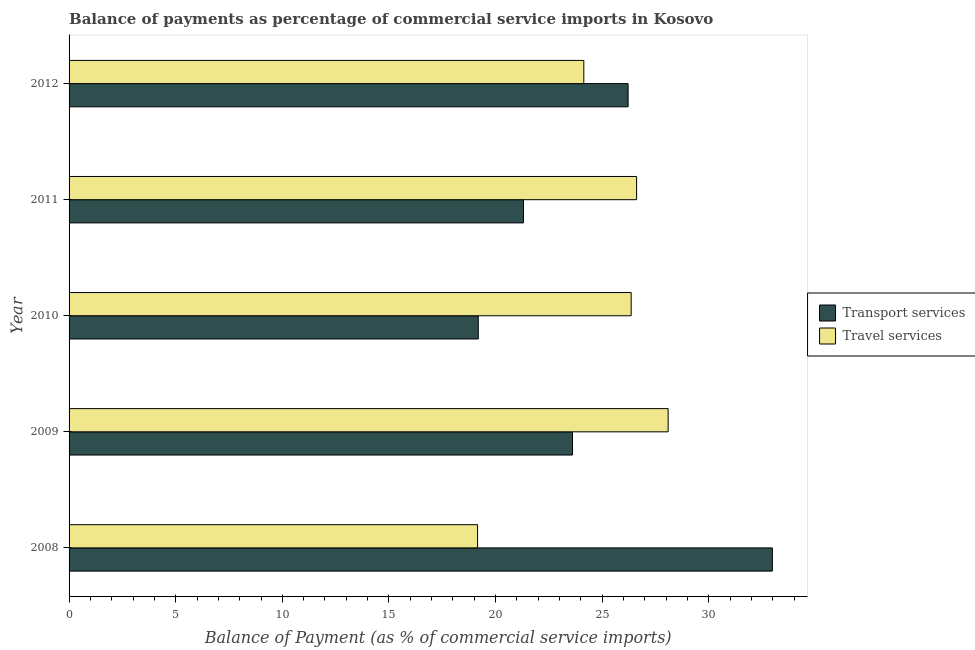How many different coloured bars are there?
Make the answer very short. 2. How many groups of bars are there?
Offer a very short reply. 5. Are the number of bars per tick equal to the number of legend labels?
Make the answer very short. Yes. Are the number of bars on each tick of the Y-axis equal?
Ensure brevity in your answer.  Yes. How many bars are there on the 1st tick from the bottom?
Provide a short and direct response. 2. What is the label of the 5th group of bars from the top?
Your answer should be compact. 2008. What is the balance of payments of travel services in 2008?
Your answer should be very brief. 19.16. Across all years, what is the maximum balance of payments of transport services?
Keep it short and to the point. 32.98. Across all years, what is the minimum balance of payments of travel services?
Provide a short and direct response. 19.16. In which year was the balance of payments of travel services maximum?
Your response must be concise. 2009. In which year was the balance of payments of travel services minimum?
Provide a short and direct response. 2008. What is the total balance of payments of travel services in the graph?
Keep it short and to the point. 124.36. What is the difference between the balance of payments of transport services in 2011 and that in 2012?
Your response must be concise. -4.91. What is the difference between the balance of payments of transport services in 2011 and the balance of payments of travel services in 2008?
Make the answer very short. 2.15. What is the average balance of payments of travel services per year?
Your answer should be compact. 24.87. In the year 2012, what is the difference between the balance of payments of travel services and balance of payments of transport services?
Offer a terse response. -2.08. What is the ratio of the balance of payments of travel services in 2009 to that in 2010?
Offer a terse response. 1.07. Is the balance of payments of transport services in 2009 less than that in 2011?
Keep it short and to the point. No. What is the difference between the highest and the second highest balance of payments of travel services?
Ensure brevity in your answer.  1.48. What is the difference between the highest and the lowest balance of payments of transport services?
Offer a terse response. 13.79. Is the sum of the balance of payments of transport services in 2009 and 2010 greater than the maximum balance of payments of travel services across all years?
Make the answer very short. Yes. What does the 2nd bar from the top in 2011 represents?
Provide a short and direct response. Transport services. What does the 2nd bar from the bottom in 2008 represents?
Give a very brief answer. Travel services. How many years are there in the graph?
Offer a terse response. 5. What is the difference between two consecutive major ticks on the X-axis?
Ensure brevity in your answer.  5. How are the legend labels stacked?
Provide a short and direct response. Vertical. What is the title of the graph?
Offer a very short reply. Balance of payments as percentage of commercial service imports in Kosovo. Does "Male labor force" appear as one of the legend labels in the graph?
Provide a succinct answer. No. What is the label or title of the X-axis?
Provide a short and direct response. Balance of Payment (as % of commercial service imports). What is the label or title of the Y-axis?
Your response must be concise. Year. What is the Balance of Payment (as % of commercial service imports) of Transport services in 2008?
Your answer should be very brief. 32.98. What is the Balance of Payment (as % of commercial service imports) of Travel services in 2008?
Provide a short and direct response. 19.16. What is the Balance of Payment (as % of commercial service imports) of Transport services in 2009?
Make the answer very short. 23.61. What is the Balance of Payment (as % of commercial service imports) in Travel services in 2009?
Your answer should be very brief. 28.09. What is the Balance of Payment (as % of commercial service imports) of Transport services in 2010?
Make the answer very short. 19.19. What is the Balance of Payment (as % of commercial service imports) of Travel services in 2010?
Keep it short and to the point. 26.36. What is the Balance of Payment (as % of commercial service imports) in Transport services in 2011?
Your answer should be compact. 21.31. What is the Balance of Payment (as % of commercial service imports) of Travel services in 2011?
Offer a terse response. 26.61. What is the Balance of Payment (as % of commercial service imports) of Transport services in 2012?
Provide a short and direct response. 26.21. What is the Balance of Payment (as % of commercial service imports) in Travel services in 2012?
Offer a very short reply. 24.14. Across all years, what is the maximum Balance of Payment (as % of commercial service imports) of Transport services?
Keep it short and to the point. 32.98. Across all years, what is the maximum Balance of Payment (as % of commercial service imports) of Travel services?
Provide a succinct answer. 28.09. Across all years, what is the minimum Balance of Payment (as % of commercial service imports) in Transport services?
Provide a short and direct response. 19.19. Across all years, what is the minimum Balance of Payment (as % of commercial service imports) of Travel services?
Give a very brief answer. 19.16. What is the total Balance of Payment (as % of commercial service imports) in Transport services in the graph?
Offer a terse response. 123.3. What is the total Balance of Payment (as % of commercial service imports) of Travel services in the graph?
Offer a very short reply. 124.36. What is the difference between the Balance of Payment (as % of commercial service imports) of Transport services in 2008 and that in 2009?
Make the answer very short. 9.37. What is the difference between the Balance of Payment (as % of commercial service imports) of Travel services in 2008 and that in 2009?
Ensure brevity in your answer.  -8.94. What is the difference between the Balance of Payment (as % of commercial service imports) of Transport services in 2008 and that in 2010?
Give a very brief answer. 13.79. What is the difference between the Balance of Payment (as % of commercial service imports) in Travel services in 2008 and that in 2010?
Your answer should be compact. -7.2. What is the difference between the Balance of Payment (as % of commercial service imports) in Transport services in 2008 and that in 2011?
Make the answer very short. 11.67. What is the difference between the Balance of Payment (as % of commercial service imports) of Travel services in 2008 and that in 2011?
Provide a short and direct response. -7.46. What is the difference between the Balance of Payment (as % of commercial service imports) in Transport services in 2008 and that in 2012?
Provide a succinct answer. 6.77. What is the difference between the Balance of Payment (as % of commercial service imports) in Travel services in 2008 and that in 2012?
Ensure brevity in your answer.  -4.98. What is the difference between the Balance of Payment (as % of commercial service imports) in Transport services in 2009 and that in 2010?
Your answer should be compact. 4.42. What is the difference between the Balance of Payment (as % of commercial service imports) in Travel services in 2009 and that in 2010?
Your response must be concise. 1.73. What is the difference between the Balance of Payment (as % of commercial service imports) in Transport services in 2009 and that in 2011?
Your answer should be compact. 2.3. What is the difference between the Balance of Payment (as % of commercial service imports) of Travel services in 2009 and that in 2011?
Offer a terse response. 1.48. What is the difference between the Balance of Payment (as % of commercial service imports) of Transport services in 2009 and that in 2012?
Make the answer very short. -2.61. What is the difference between the Balance of Payment (as % of commercial service imports) in Travel services in 2009 and that in 2012?
Give a very brief answer. 3.95. What is the difference between the Balance of Payment (as % of commercial service imports) in Transport services in 2010 and that in 2011?
Offer a terse response. -2.12. What is the difference between the Balance of Payment (as % of commercial service imports) of Travel services in 2010 and that in 2011?
Offer a very short reply. -0.25. What is the difference between the Balance of Payment (as % of commercial service imports) of Transport services in 2010 and that in 2012?
Your response must be concise. -7.03. What is the difference between the Balance of Payment (as % of commercial service imports) of Travel services in 2010 and that in 2012?
Your answer should be very brief. 2.22. What is the difference between the Balance of Payment (as % of commercial service imports) in Transport services in 2011 and that in 2012?
Make the answer very short. -4.91. What is the difference between the Balance of Payment (as % of commercial service imports) in Travel services in 2011 and that in 2012?
Make the answer very short. 2.47. What is the difference between the Balance of Payment (as % of commercial service imports) of Transport services in 2008 and the Balance of Payment (as % of commercial service imports) of Travel services in 2009?
Offer a very short reply. 4.89. What is the difference between the Balance of Payment (as % of commercial service imports) in Transport services in 2008 and the Balance of Payment (as % of commercial service imports) in Travel services in 2010?
Your answer should be very brief. 6.62. What is the difference between the Balance of Payment (as % of commercial service imports) of Transport services in 2008 and the Balance of Payment (as % of commercial service imports) of Travel services in 2011?
Offer a terse response. 6.37. What is the difference between the Balance of Payment (as % of commercial service imports) in Transport services in 2008 and the Balance of Payment (as % of commercial service imports) in Travel services in 2012?
Your answer should be very brief. 8.84. What is the difference between the Balance of Payment (as % of commercial service imports) in Transport services in 2009 and the Balance of Payment (as % of commercial service imports) in Travel services in 2010?
Provide a short and direct response. -2.75. What is the difference between the Balance of Payment (as % of commercial service imports) in Transport services in 2009 and the Balance of Payment (as % of commercial service imports) in Travel services in 2011?
Your answer should be very brief. -3.01. What is the difference between the Balance of Payment (as % of commercial service imports) of Transport services in 2009 and the Balance of Payment (as % of commercial service imports) of Travel services in 2012?
Make the answer very short. -0.53. What is the difference between the Balance of Payment (as % of commercial service imports) of Transport services in 2010 and the Balance of Payment (as % of commercial service imports) of Travel services in 2011?
Your answer should be very brief. -7.42. What is the difference between the Balance of Payment (as % of commercial service imports) of Transport services in 2010 and the Balance of Payment (as % of commercial service imports) of Travel services in 2012?
Your answer should be very brief. -4.95. What is the difference between the Balance of Payment (as % of commercial service imports) of Transport services in 2011 and the Balance of Payment (as % of commercial service imports) of Travel services in 2012?
Offer a terse response. -2.83. What is the average Balance of Payment (as % of commercial service imports) of Transport services per year?
Give a very brief answer. 24.66. What is the average Balance of Payment (as % of commercial service imports) of Travel services per year?
Your answer should be very brief. 24.87. In the year 2008, what is the difference between the Balance of Payment (as % of commercial service imports) in Transport services and Balance of Payment (as % of commercial service imports) in Travel services?
Your answer should be compact. 13.82. In the year 2009, what is the difference between the Balance of Payment (as % of commercial service imports) in Transport services and Balance of Payment (as % of commercial service imports) in Travel services?
Keep it short and to the point. -4.48. In the year 2010, what is the difference between the Balance of Payment (as % of commercial service imports) of Transport services and Balance of Payment (as % of commercial service imports) of Travel services?
Make the answer very short. -7.17. In the year 2011, what is the difference between the Balance of Payment (as % of commercial service imports) in Transport services and Balance of Payment (as % of commercial service imports) in Travel services?
Make the answer very short. -5.3. In the year 2012, what is the difference between the Balance of Payment (as % of commercial service imports) in Transport services and Balance of Payment (as % of commercial service imports) in Travel services?
Your answer should be compact. 2.08. What is the ratio of the Balance of Payment (as % of commercial service imports) of Transport services in 2008 to that in 2009?
Your answer should be compact. 1.4. What is the ratio of the Balance of Payment (as % of commercial service imports) of Travel services in 2008 to that in 2009?
Offer a very short reply. 0.68. What is the ratio of the Balance of Payment (as % of commercial service imports) in Transport services in 2008 to that in 2010?
Ensure brevity in your answer.  1.72. What is the ratio of the Balance of Payment (as % of commercial service imports) of Travel services in 2008 to that in 2010?
Provide a succinct answer. 0.73. What is the ratio of the Balance of Payment (as % of commercial service imports) in Transport services in 2008 to that in 2011?
Ensure brevity in your answer.  1.55. What is the ratio of the Balance of Payment (as % of commercial service imports) in Travel services in 2008 to that in 2011?
Give a very brief answer. 0.72. What is the ratio of the Balance of Payment (as % of commercial service imports) in Transport services in 2008 to that in 2012?
Provide a short and direct response. 1.26. What is the ratio of the Balance of Payment (as % of commercial service imports) of Travel services in 2008 to that in 2012?
Keep it short and to the point. 0.79. What is the ratio of the Balance of Payment (as % of commercial service imports) of Transport services in 2009 to that in 2010?
Keep it short and to the point. 1.23. What is the ratio of the Balance of Payment (as % of commercial service imports) of Travel services in 2009 to that in 2010?
Your response must be concise. 1.07. What is the ratio of the Balance of Payment (as % of commercial service imports) in Transport services in 2009 to that in 2011?
Provide a succinct answer. 1.11. What is the ratio of the Balance of Payment (as % of commercial service imports) of Travel services in 2009 to that in 2011?
Provide a short and direct response. 1.06. What is the ratio of the Balance of Payment (as % of commercial service imports) of Transport services in 2009 to that in 2012?
Offer a terse response. 0.9. What is the ratio of the Balance of Payment (as % of commercial service imports) in Travel services in 2009 to that in 2012?
Keep it short and to the point. 1.16. What is the ratio of the Balance of Payment (as % of commercial service imports) of Transport services in 2010 to that in 2011?
Your answer should be compact. 0.9. What is the ratio of the Balance of Payment (as % of commercial service imports) in Transport services in 2010 to that in 2012?
Ensure brevity in your answer.  0.73. What is the ratio of the Balance of Payment (as % of commercial service imports) in Travel services in 2010 to that in 2012?
Provide a succinct answer. 1.09. What is the ratio of the Balance of Payment (as % of commercial service imports) in Transport services in 2011 to that in 2012?
Your answer should be very brief. 0.81. What is the ratio of the Balance of Payment (as % of commercial service imports) in Travel services in 2011 to that in 2012?
Provide a short and direct response. 1.1. What is the difference between the highest and the second highest Balance of Payment (as % of commercial service imports) of Transport services?
Provide a short and direct response. 6.77. What is the difference between the highest and the second highest Balance of Payment (as % of commercial service imports) of Travel services?
Your answer should be compact. 1.48. What is the difference between the highest and the lowest Balance of Payment (as % of commercial service imports) of Transport services?
Your answer should be very brief. 13.79. What is the difference between the highest and the lowest Balance of Payment (as % of commercial service imports) in Travel services?
Give a very brief answer. 8.94. 